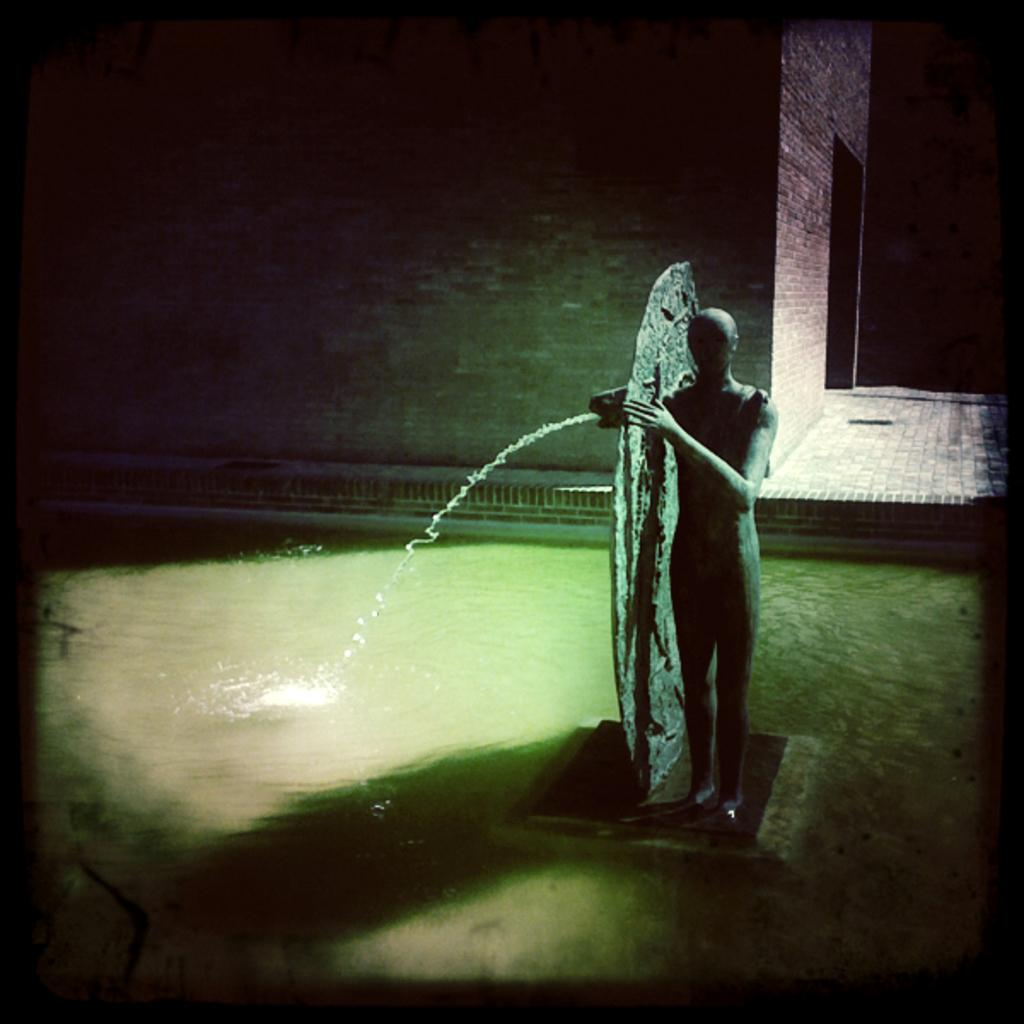What is the main subject in the center of the image? There is a statue and a water fountain in the center of the image. What is the condition of the water in the image? Water is visible at the bottom of the image. What can be seen in the background of the image? There is a wall and a building in the background of the image. What type of paper can be seen in the image? There is no paper present in the image. Can you tell me how many airports are visible in the image? There are no airports visible in the image. 